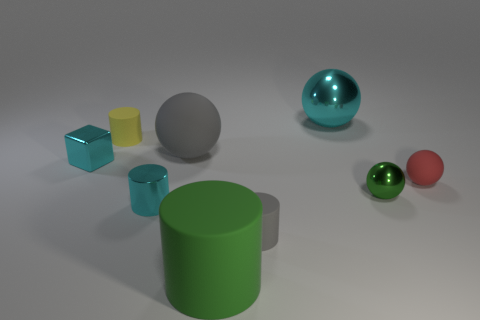There is a ball that is both to the left of the red object and in front of the small metal cube; how big is it?
Keep it short and to the point. Small. There is a tiny yellow rubber thing; is it the same shape as the green thing that is to the left of the large metal sphere?
Make the answer very short. Yes. What number of things are either small shiny things that are in front of the cyan shiny cube or large green cylinders?
Offer a very short reply. 3. Is the material of the tiny gray thing the same as the cyan thing that is behind the cyan shiny block?
Your answer should be very brief. No. What is the shape of the gray matte object that is behind the tiny metal ball that is in front of the tiny red matte thing?
Your answer should be very brief. Sphere. There is a metallic block; does it have the same color as the metallic sphere that is behind the small green object?
Provide a succinct answer. Yes. What shape is the red matte thing?
Offer a very short reply. Sphere. What is the size of the green object that is behind the large matte thing that is in front of the small gray rubber thing?
Your answer should be compact. Small. Are there an equal number of cylinders to the right of the cyan metal sphere and small things on the right side of the big green cylinder?
Your answer should be very brief. No. There is a object that is both on the left side of the small metal cylinder and behind the cyan cube; what material is it?
Offer a very short reply. Rubber. 